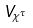<formula> <loc_0><loc_0><loc_500><loc_500>V _ { \chi ^ { \tau } }</formula> 